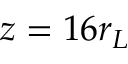<formula> <loc_0><loc_0><loc_500><loc_500>z = 1 6 r _ { L }</formula> 